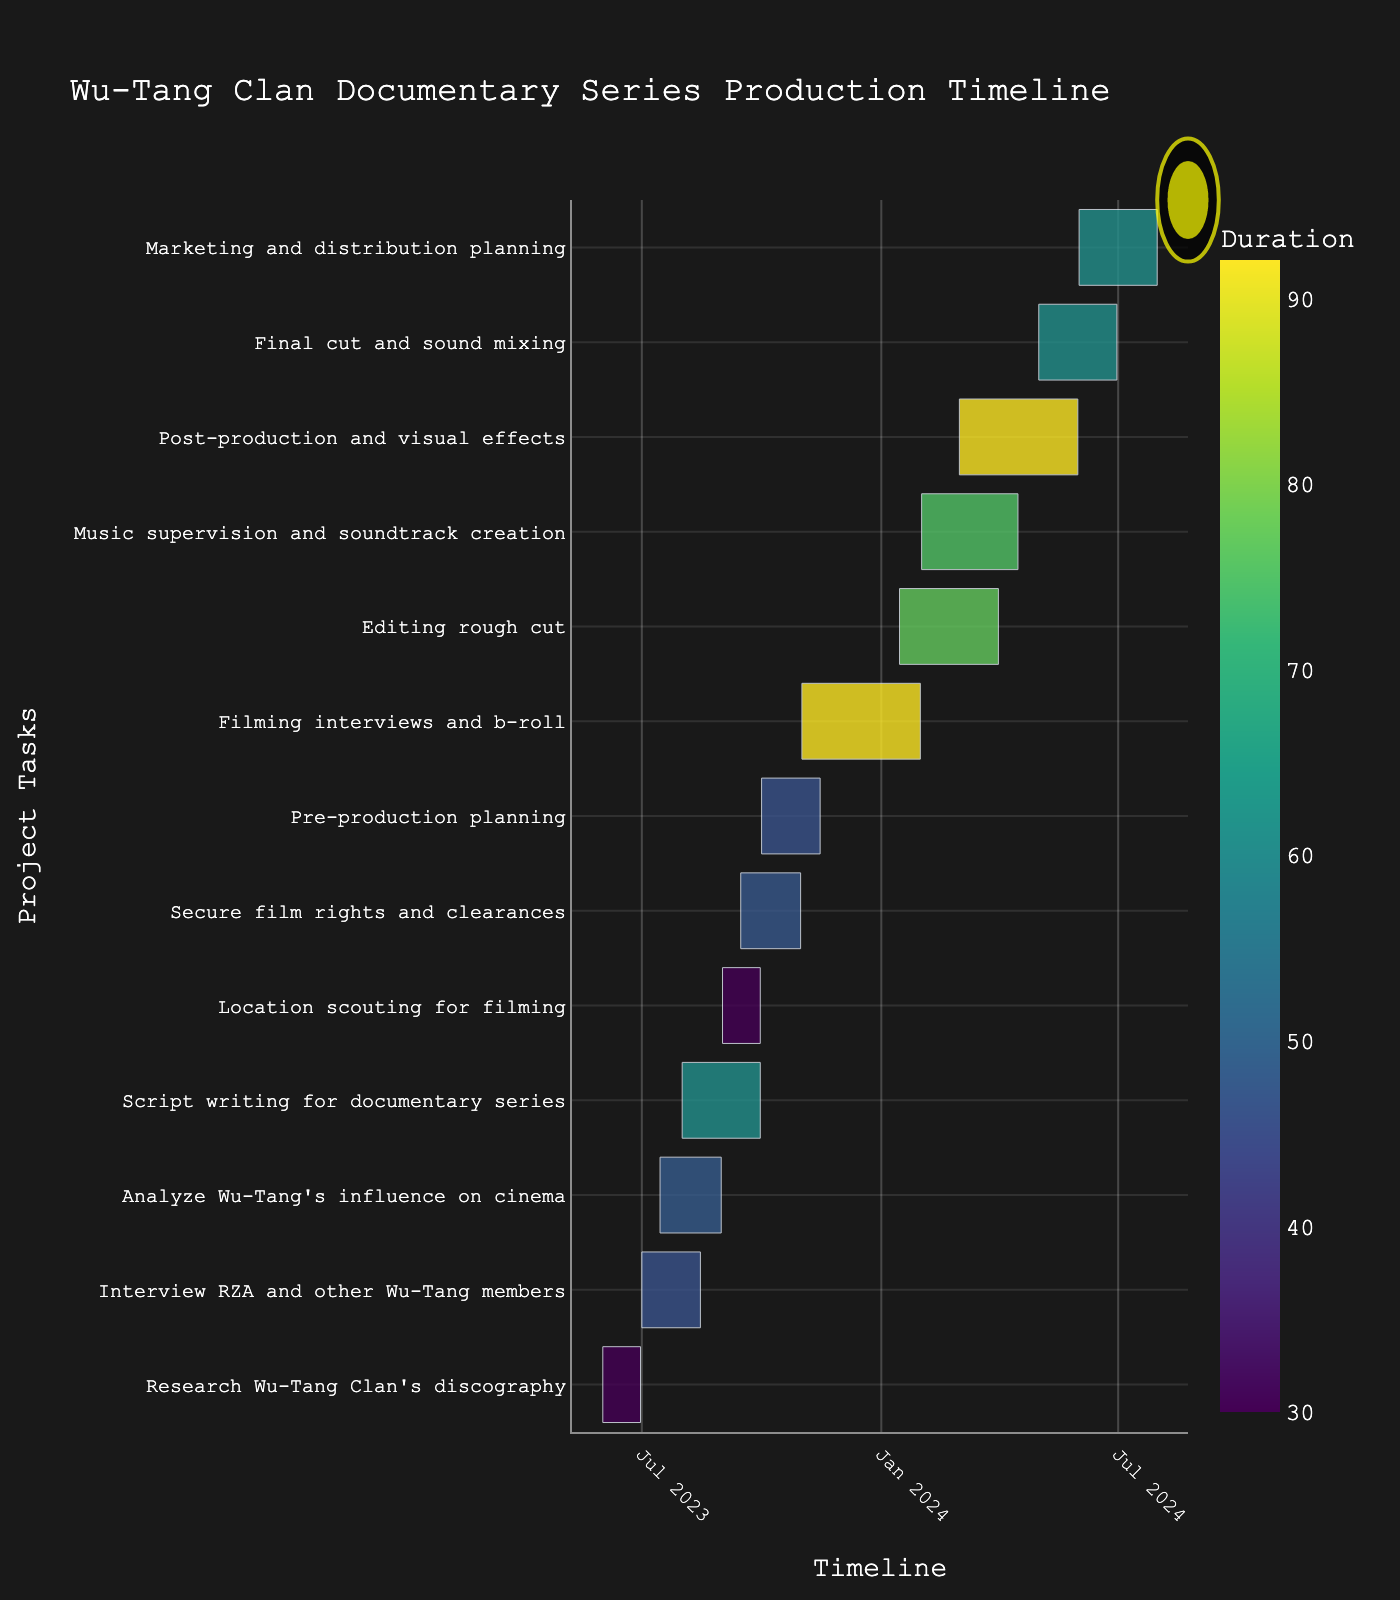What's the title of the Gantt chart? The title of the chart is written at the top of the figure. It typically provides an overview of what the chart represents.
Answer: Wu-Tang Clan Documentary Series Production Timeline How long is the "Script writing for documentary series" task? Look for the task labeled "Script writing for documentary series" on the y-axis and follow it to find the duration marked in the color bar.
Answer: 61 days Which task has the longest duration, and what is its length? Identify the task bar that extends the furthest on the x-axis. The hover template or the color bar will also provide duration details.
Answer: Filming interviews and b-roll, 92 days What are the start and end dates for the "Location scouting for filming" task? Locate the bar for "Location scouting for filming" and read off the start and end dates from the x-axis or the detailed hover information.
Answer: Start: September 1, 2023, End: September 30, 2023 Which two tasks overlap in July 2023, and by how many days do they overlap? Look at the position of bars in July 2023 and identify the tasks. Calculate the overlap by comparing their start and end dates.
Answer: "Interview RZA and other Wu-Tang members" and "Analyze Wu-Tang's influence on cinema" overlap by 17 days What is the duration of the tasks that start in June 2023? Identify tasks starting in June 2023 and sum up their durations.
Answer: The duration of "Research Wu-Tang Clan's discography" is 30 days Which task ends last? Trace the end dates of all tasks on the x-axis to find the latest one.
Answer: Marketing and distribution planning How many tasks begin in September 2023? Count the bars that start in September 2023 on the y-axis.
Answer: 3 tasks How long does the "Music supervision and soundtrack creation" task take compared to "Editing rough cut"? Compare the duration bars or use the hover information to find the values, then subtract the shorter duration from the longer one. The "Music supervision and soundtrack creation" task is 75 days, while "Editing rough cut" is 77 days.
Answer: 2 days less When does the "Post-production and visual effects" task start and finish? Check the bar labeled "Post-production and visual effects" on the y-axis and refer to the x-axis or hover template for start and end dates.
Answer: Start: March 1, 2024, End: May 31, 2024 